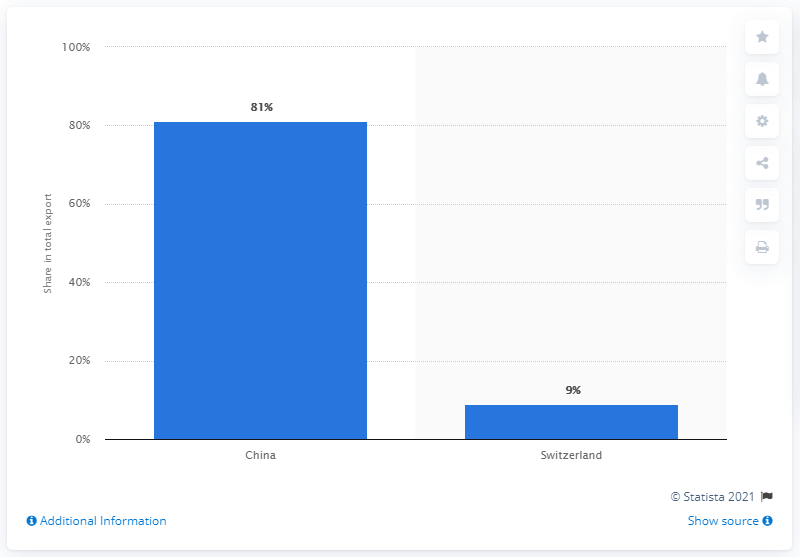What was the main export partner of Mongolia in 2019?
 China 